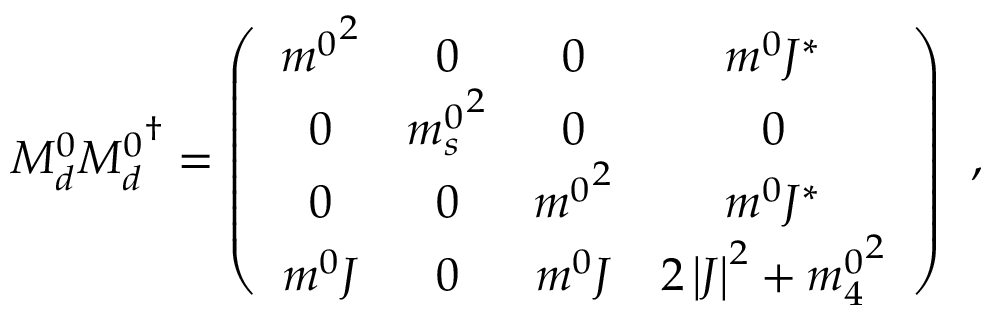<formula> <loc_0><loc_0><loc_500><loc_500>M _ { d } ^ { 0 } { M _ { d } ^ { 0 } } ^ { \dagger } = \left ( \begin{array} { c c c c } { { { m ^ { 0 } } ^ { 2 } } } & { 0 } & { 0 } & { { m ^ { 0 } J ^ { \ast } } } \\ { 0 } & { { { m _ { s } ^ { 0 } } ^ { 2 } } } & { 0 } & { 0 } \\ { 0 } & { 0 } & { { { m ^ { 0 } } ^ { 2 } } } & { { m ^ { 0 } J ^ { \ast } } } \\ { { m ^ { 0 } J } } & { 0 } & { { m ^ { 0 } J } } & { { 2 \left | J \right | ^ { 2 } + { m _ { 4 } ^ { 0 } } ^ { 2 } } } \end{array} \right ) \, ,</formula> 